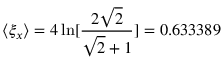Convert formula to latex. <formula><loc_0><loc_0><loc_500><loc_500>\langle \xi _ { x } \rangle = 4 \ln [ \frac { 2 \sqrt { 2 } } { \sqrt { 2 } + 1 } ] = 0 . 6 3 3 3 8 9</formula> 